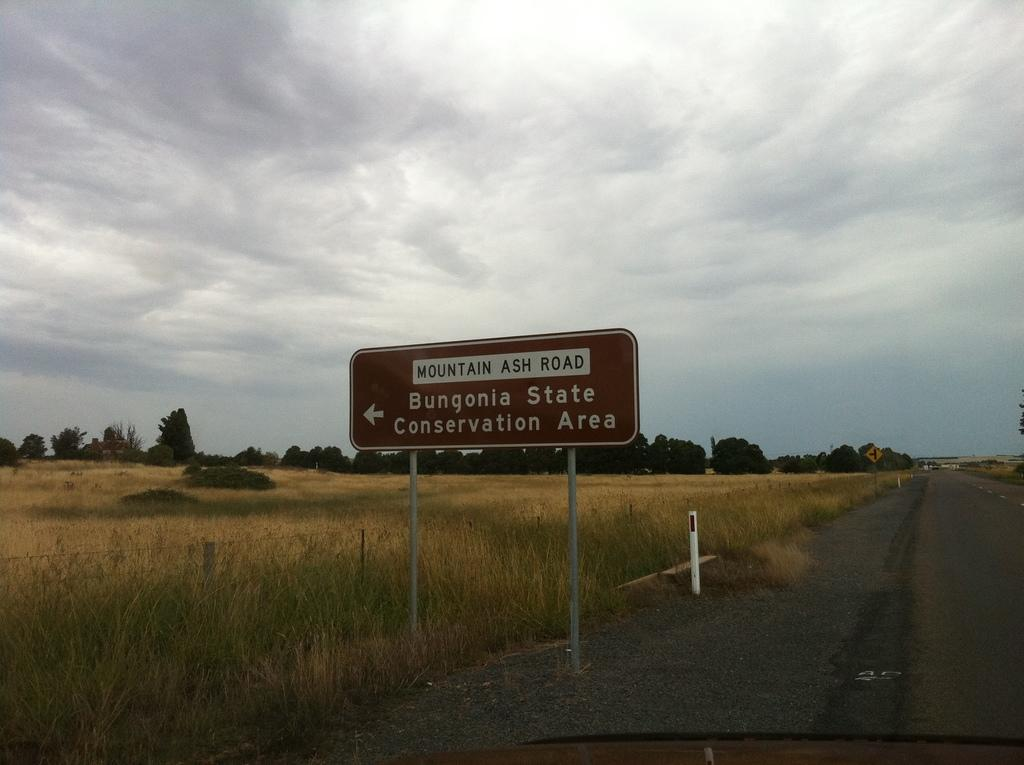<image>
Relay a brief, clear account of the picture shown. A sign for Bungonia State Conservation Area has an arrow pointing to the left. 